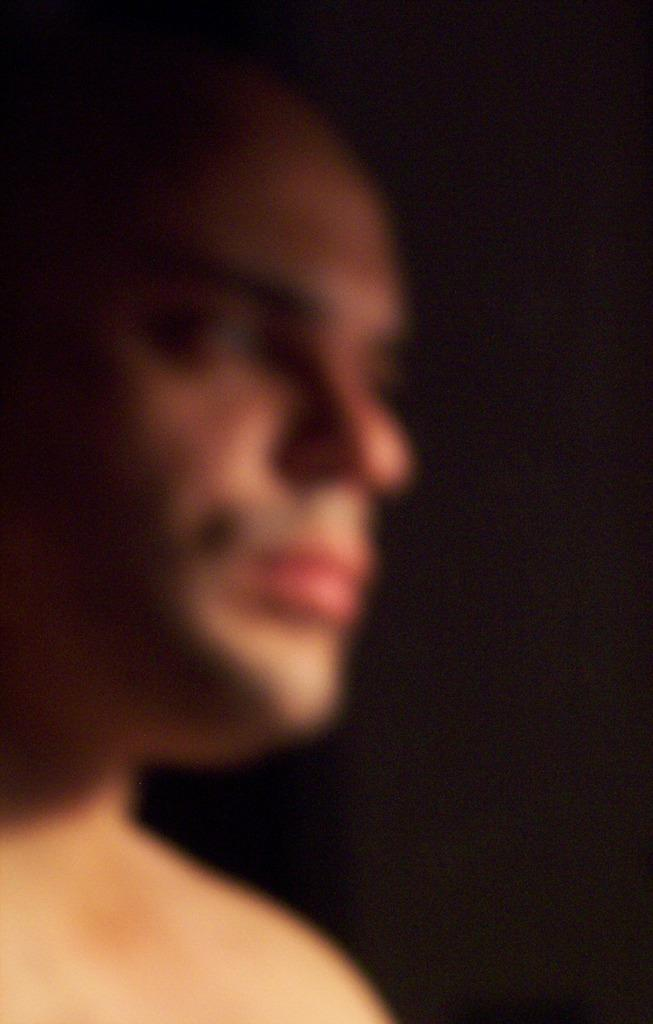Who is the main subject in the image? There is a man in the image. Can you describe the quality of the image? The image is blurred. What can be observed about the background of the image? The background of the image is dark. What type of food is the man holding in the image? There is no food visible in the image, as it is blurred and only shows a man in a dark background. 